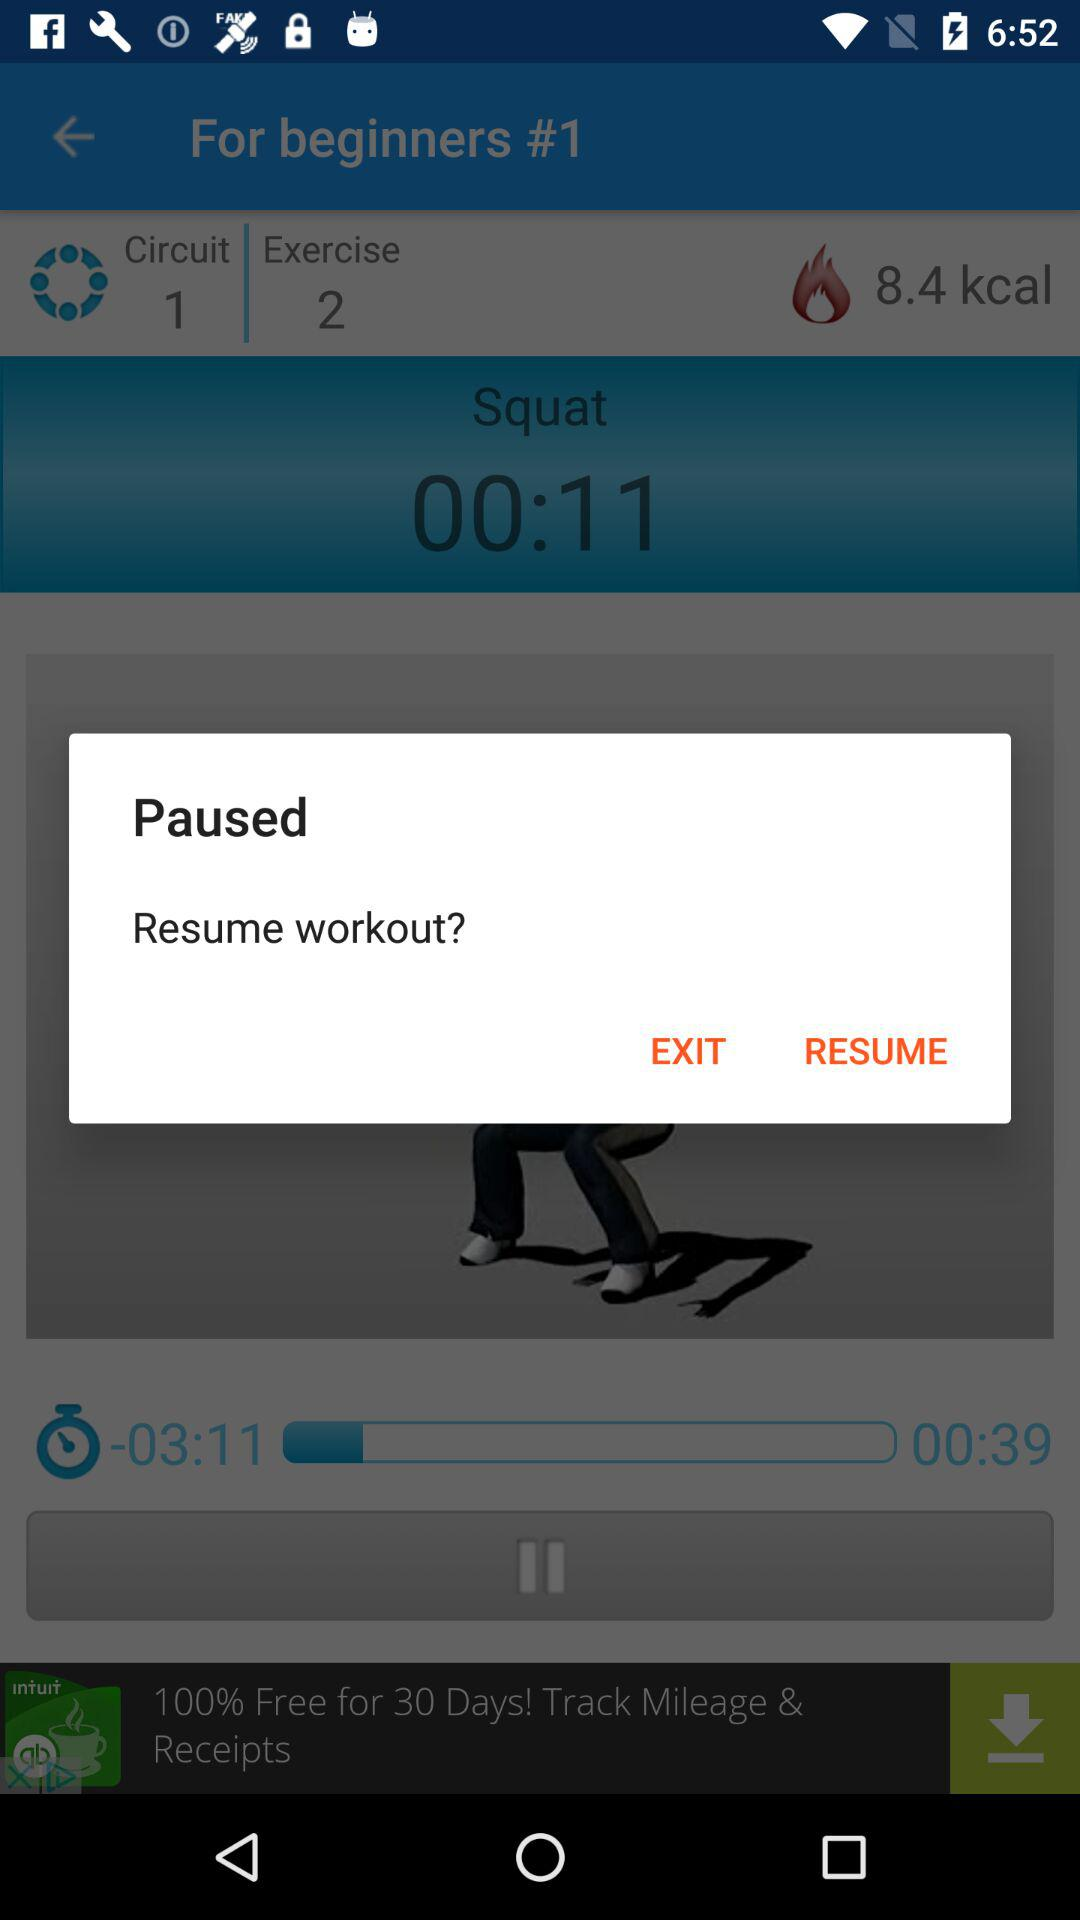How many people reviewed the app? The people who reviewed the app are 231,504. 